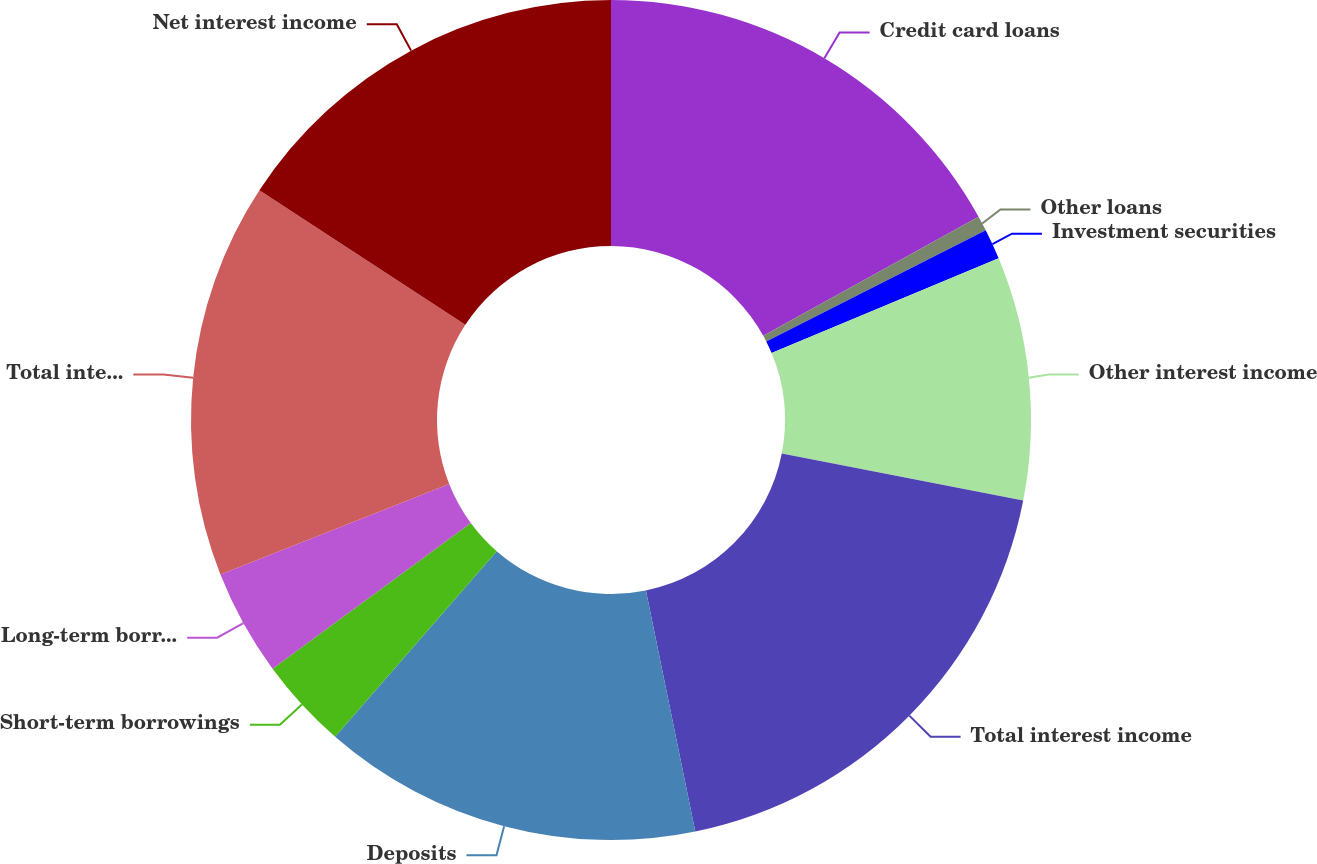Convert chart. <chart><loc_0><loc_0><loc_500><loc_500><pie_chart><fcel>Credit card loans<fcel>Other loans<fcel>Investment securities<fcel>Other interest income<fcel>Total interest income<fcel>Deposits<fcel>Short-term borrowings<fcel>Long-term borrowings<fcel>Total interest expense<fcel>Net interest income<nl><fcel>16.96%<fcel>0.58%<fcel>1.17%<fcel>9.36%<fcel>18.71%<fcel>14.62%<fcel>3.51%<fcel>4.09%<fcel>15.2%<fcel>15.79%<nl></chart> 